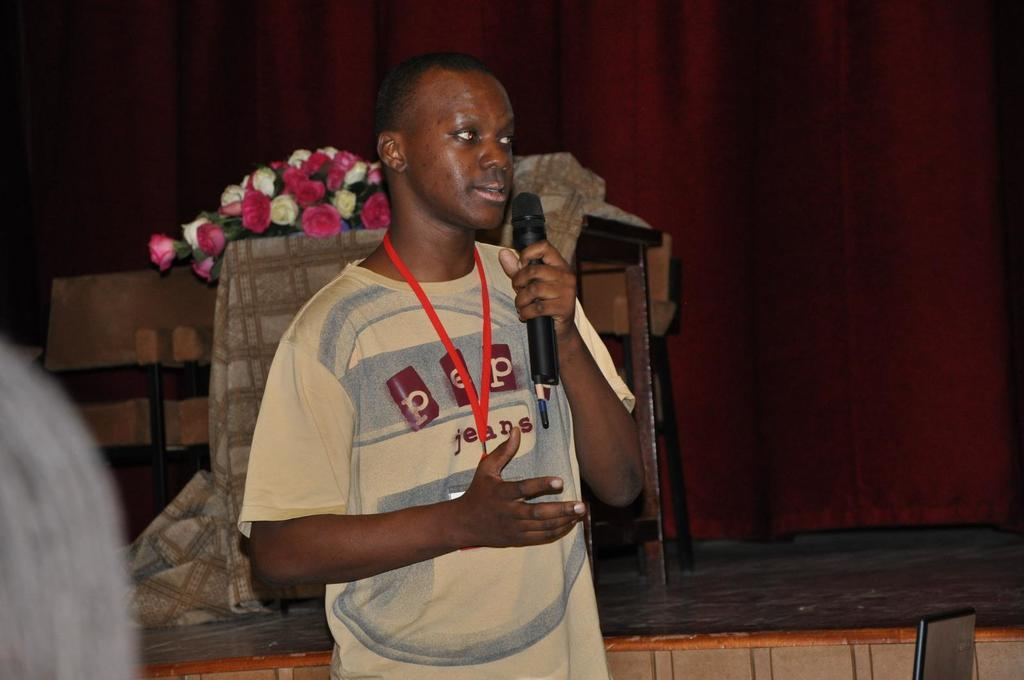What is the person in the image holding? The person is holding a microphone. What can be seen in the background of the image? There are chairs, a table, a cloth, flowers, and a curtain in the background of the image. How many items can be seen in the background? There are six items visible in the background: chairs, a table, a cloth, flowers, and a curtain. What type of scarf is draped over the wood in the image? There is no scarf or wood present in the image. What type of stew is being served on the table in the image? There is no stew present in the image; the table is in the background and does not have any food items on it. 